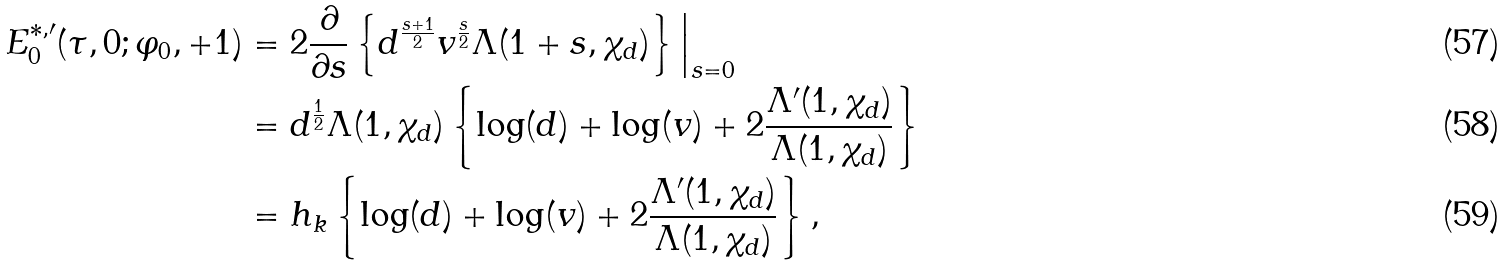Convert formula to latex. <formula><loc_0><loc_0><loc_500><loc_500>E _ { 0 } ^ { * , \prime } ( \tau , 0 ; \varphi _ { 0 } , + 1 ) & = 2 \frac { \partial } { \partial s } \left \{ d ^ { \frac { s + 1 } { 2 } } v ^ { \frac { s } { 2 } } \Lambda ( 1 + s , \chi _ { d } ) \right \} \Big | _ { s = 0 } \\ & = d ^ { \frac { 1 } { 2 } } \Lambda ( 1 , \chi _ { d } ) \left \{ \log ( d ) + \log ( v ) + 2 \frac { \Lambda ^ { \prime } ( 1 , \chi _ { d } ) } { \Lambda ( 1 , \chi _ { d } ) } \right \} \\ & = h _ { k } \left \{ \log ( d ) + \log ( v ) + 2 \frac { \Lambda ^ { \prime } ( 1 , \chi _ { d } ) } { \Lambda ( 1 , \chi _ { d } ) } \right \} ,</formula> 